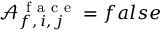<formula> <loc_0><loc_0><loc_500><loc_500>\mathcal { A } _ { f , \, i , \, j } ^ { f a c e } = f a l s e</formula> 